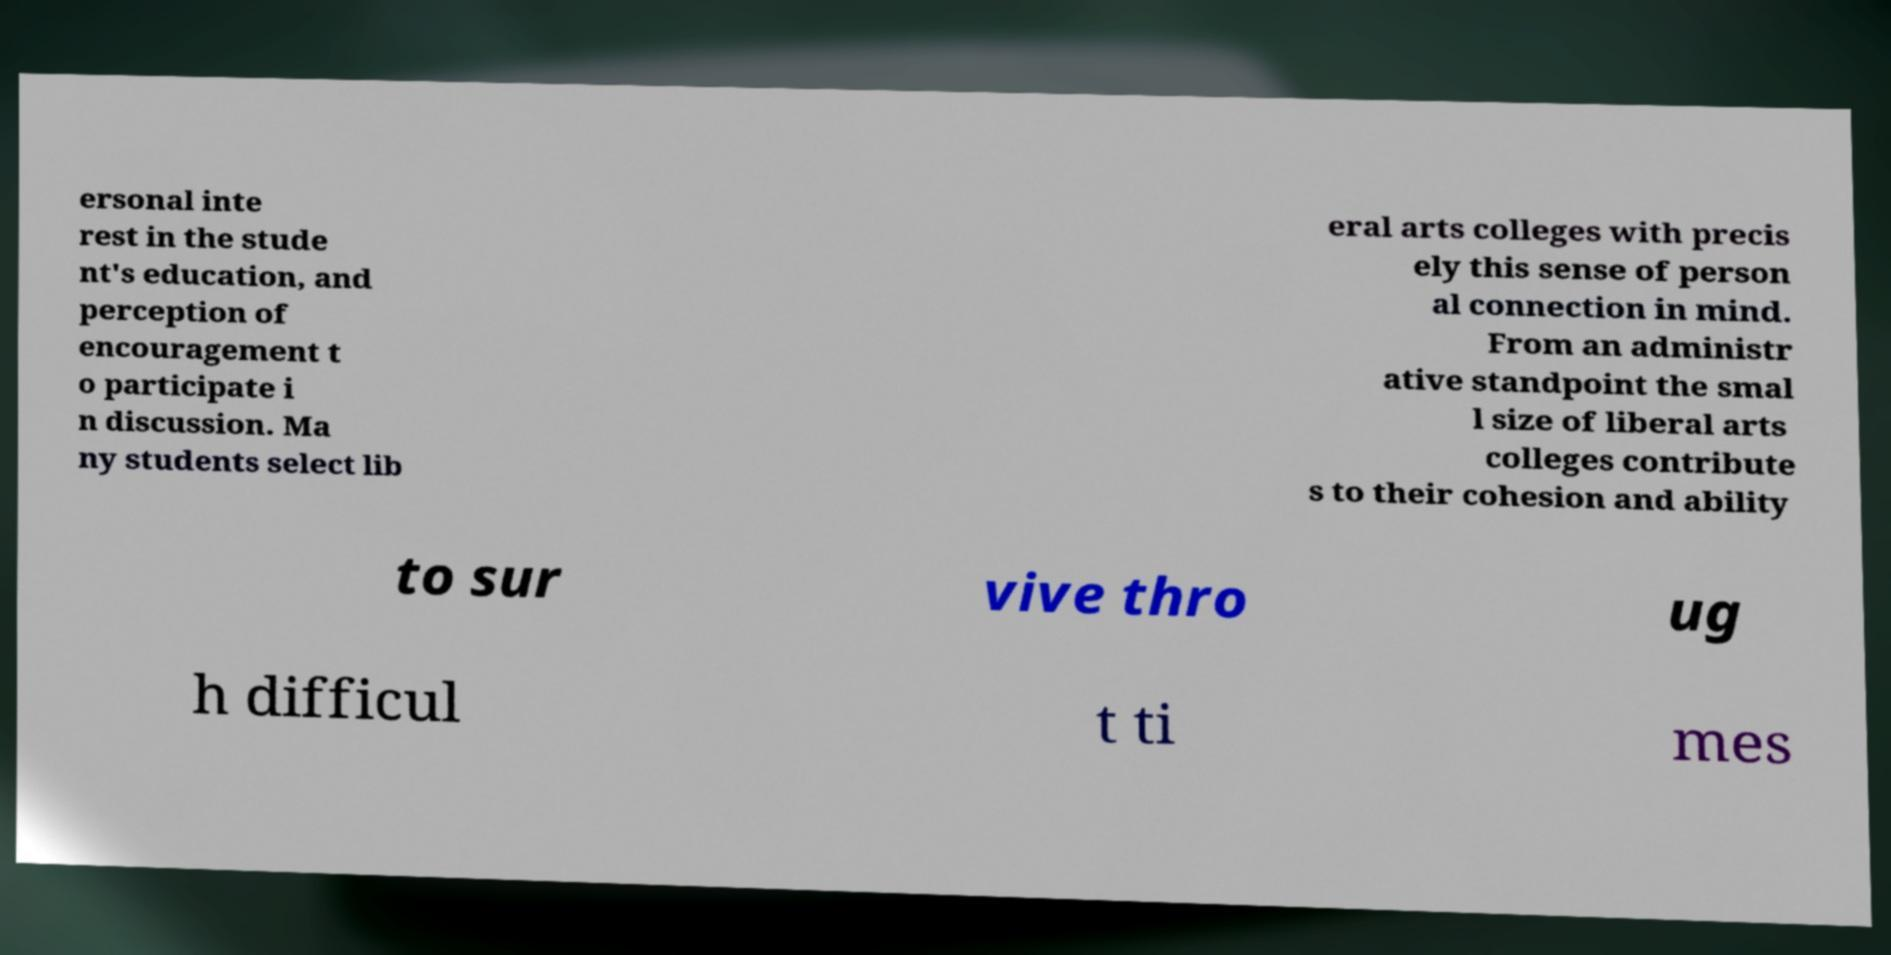What messages or text are displayed in this image? I need them in a readable, typed format. ersonal inte rest in the stude nt's education, and perception of encouragement t o participate i n discussion. Ma ny students select lib eral arts colleges with precis ely this sense of person al connection in mind. From an administr ative standpoint the smal l size of liberal arts colleges contribute s to their cohesion and ability to sur vive thro ug h difficul t ti mes 